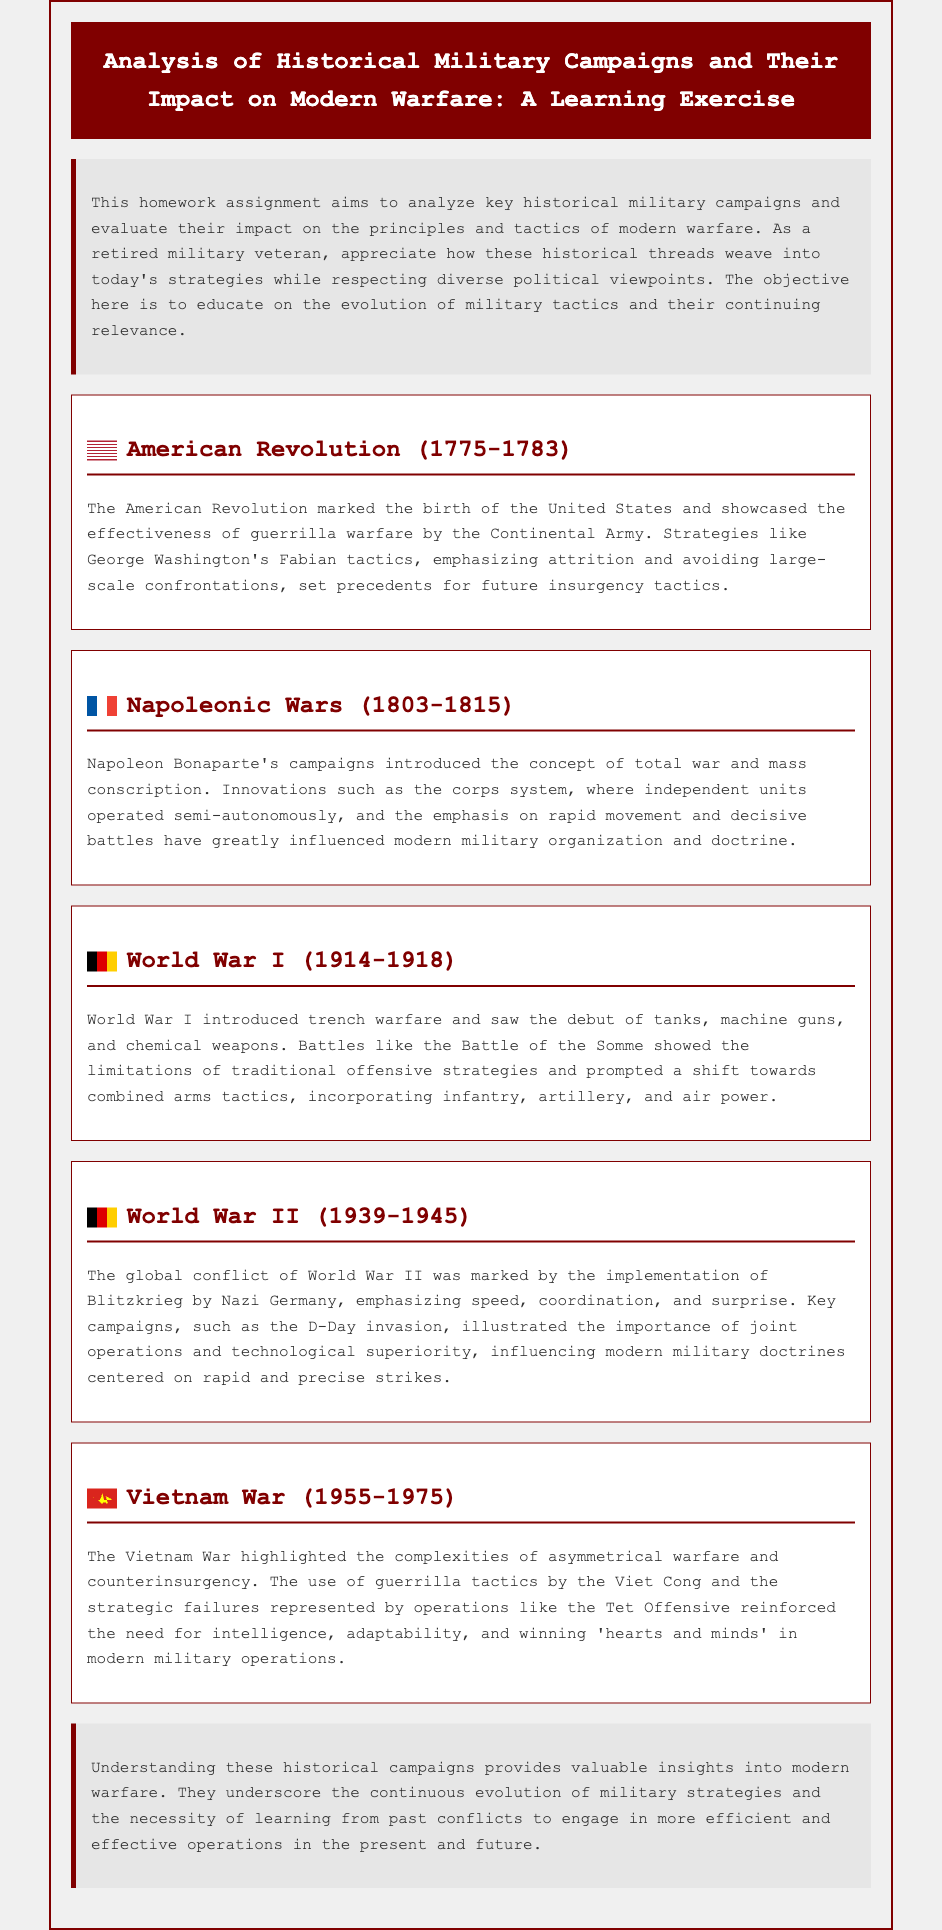what was the time period of the American Revolution? The American Revolution occurred from 1775 to 1783, as stated in the document.
Answer: 1775-1783 what military tactic did George Washington emphasize during the American Revolution? The document mentions that Washington emphasized Fabian tactics, which focused on attrition and avoiding large-scale confrontations.
Answer: Fabian tactics which war introduced trench warfare? The document indicates that World War I introduced trench warfare as a significant strategy.
Answer: World War I who was the key figure in the Napoleonic Wars? The document states Napoleon Bonaparte as the central figure in the Napoleonic Wars.
Answer: Napoleon Bonaparte what does Blitzkrieg emphasize in warfare? The document describes Blitzkrieg as emphasizing speed, coordination, and surprise in military operations.
Answer: speed, coordination, and surprise what was a significant innovation during World War I? The document highlights the debut of tanks, machine guns, and chemical weapons as significant innovations during World War I.
Answer: tanks, machine guns, and chemical weapons which conflict showcased the importance of joint operations? The document points to the D-Day invasion during World War II as a campaign illustrating the importance of joint operations.
Answer: D-Day invasion what tactic did the Viet Cong use during the Vietnam War? The document notes that the Viet Cong predominantly used guerrilla tactics in the Vietnam War.
Answer: guerrilla tactics what is the main purpose of this homework assignment? The document states that the objective is to analyze key historical military campaigns and evaluate their impact on modern warfare.
Answer: analyze key historical military campaigns 